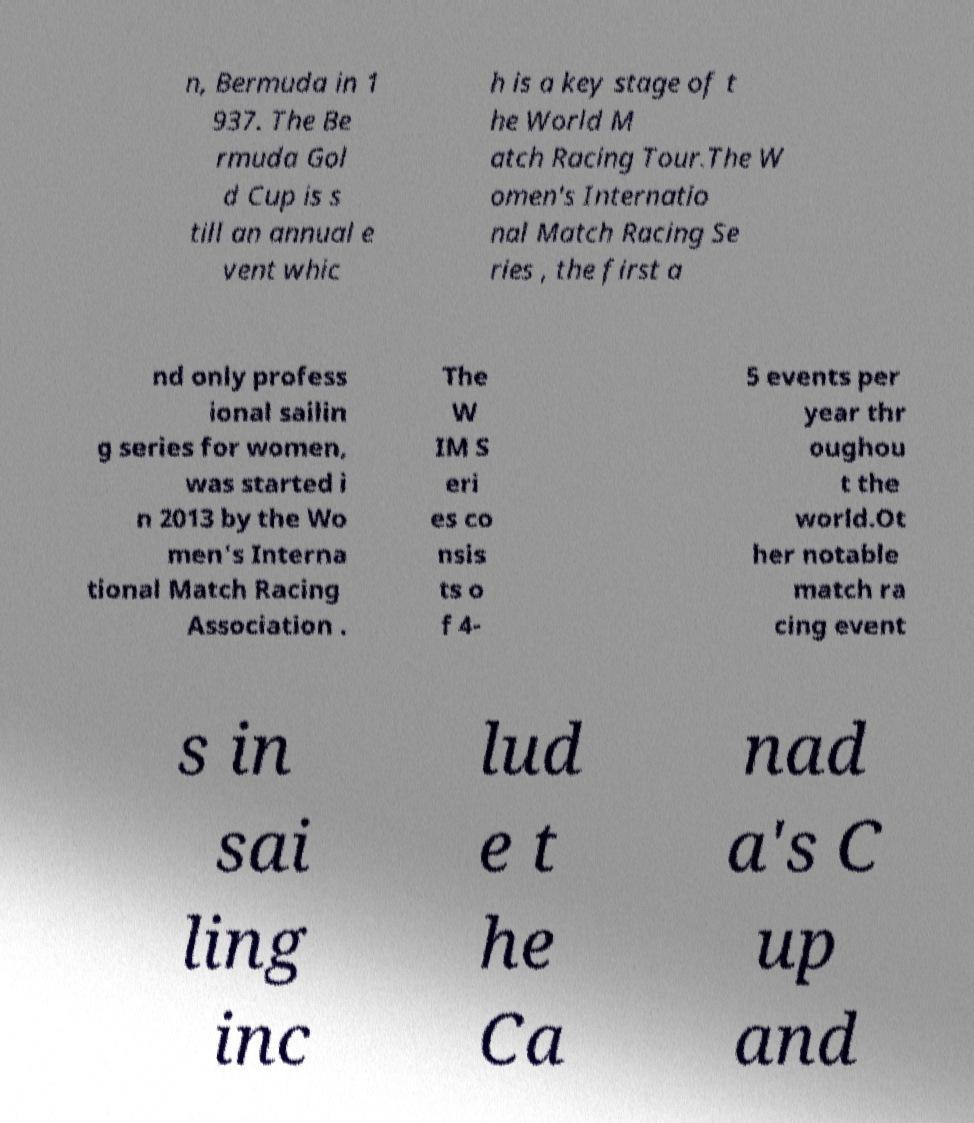Could you extract and type out the text from this image? n, Bermuda in 1 937. The Be rmuda Gol d Cup is s till an annual e vent whic h is a key stage of t he World M atch Racing Tour.The W omen's Internatio nal Match Racing Se ries , the first a nd only profess ional sailin g series for women, was started i n 2013 by the Wo men's Interna tional Match Racing Association . The W IM S eri es co nsis ts o f 4- 5 events per year thr oughou t the world.Ot her notable match ra cing event s in sai ling inc lud e t he Ca nad a's C up and 